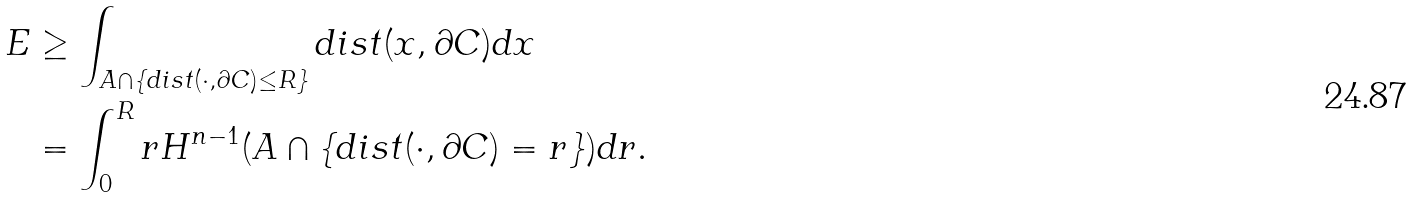<formula> <loc_0><loc_0><loc_500><loc_500>E & \geq \int _ { A \cap \{ d i s t ( \cdot , \partial C ) \leq R \} } d i s t ( x , \partial C ) d x \\ & = \int _ { 0 } ^ { R } r H ^ { n - 1 } ( A \cap \{ d i s t ( \cdot , \partial C ) = r \} ) d r .</formula> 